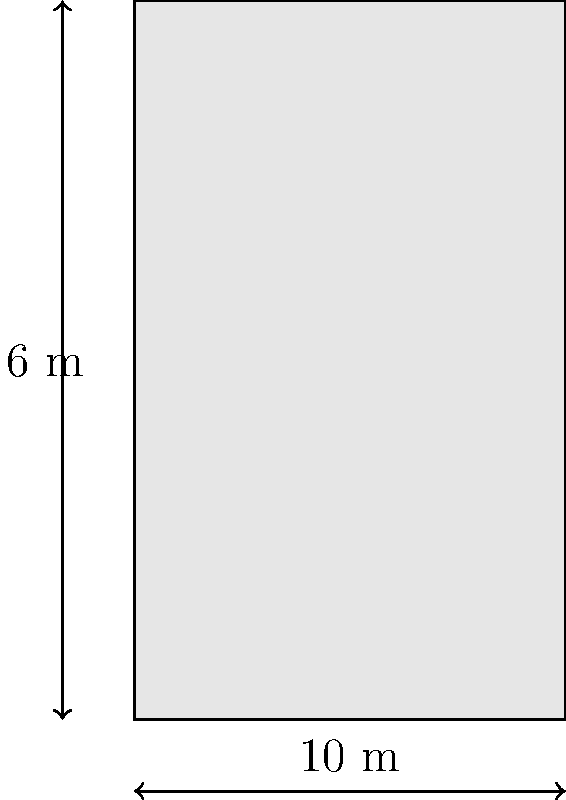As a marine engineer working on an oil exploration project, you need to calculate the volume of a cylindrical oil storage tank. The tank has a diameter of 6 meters and a height of 10 meters. What is the volume of the tank in cubic meters? Round your answer to the nearest whole number. To calculate the volume of a cylindrical tank, we use the formula:

$$V = \pi r^2 h$$

Where:
$V$ = volume
$r$ = radius
$h$ = height

Step 1: Determine the radius
The diameter is 6 meters, so the radius is half of that:
$r = 6 \div 2 = 3$ meters

Step 2: Apply the formula
$$V = \pi (3\text{ m})^2 (10\text{ m})$$

Step 3: Calculate
$$V = \pi \cdot 9\text{ m}^2 \cdot 10\text{ m}$$
$$V = 90\pi\text{ m}^3$$

Step 4: Use $\pi \approx 3.14159$ and calculate
$$V \approx 90 \cdot 3.14159\text{ m}^3$$
$$V \approx 282.74\text{ m}^3$$

Step 5: Round to the nearest whole number
$$V \approx 283\text{ m}^3$$
Answer: 283 m³ 